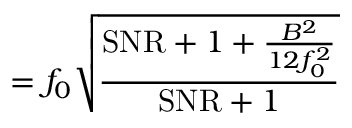<formula> <loc_0><loc_0><loc_500><loc_500>= f _ { 0 } { \sqrt { \frac { S N R + 1 + { \frac { B ^ { 2 } } { 1 2 f _ { 0 } ^ { 2 } } } } { S N R + 1 } } }</formula> 